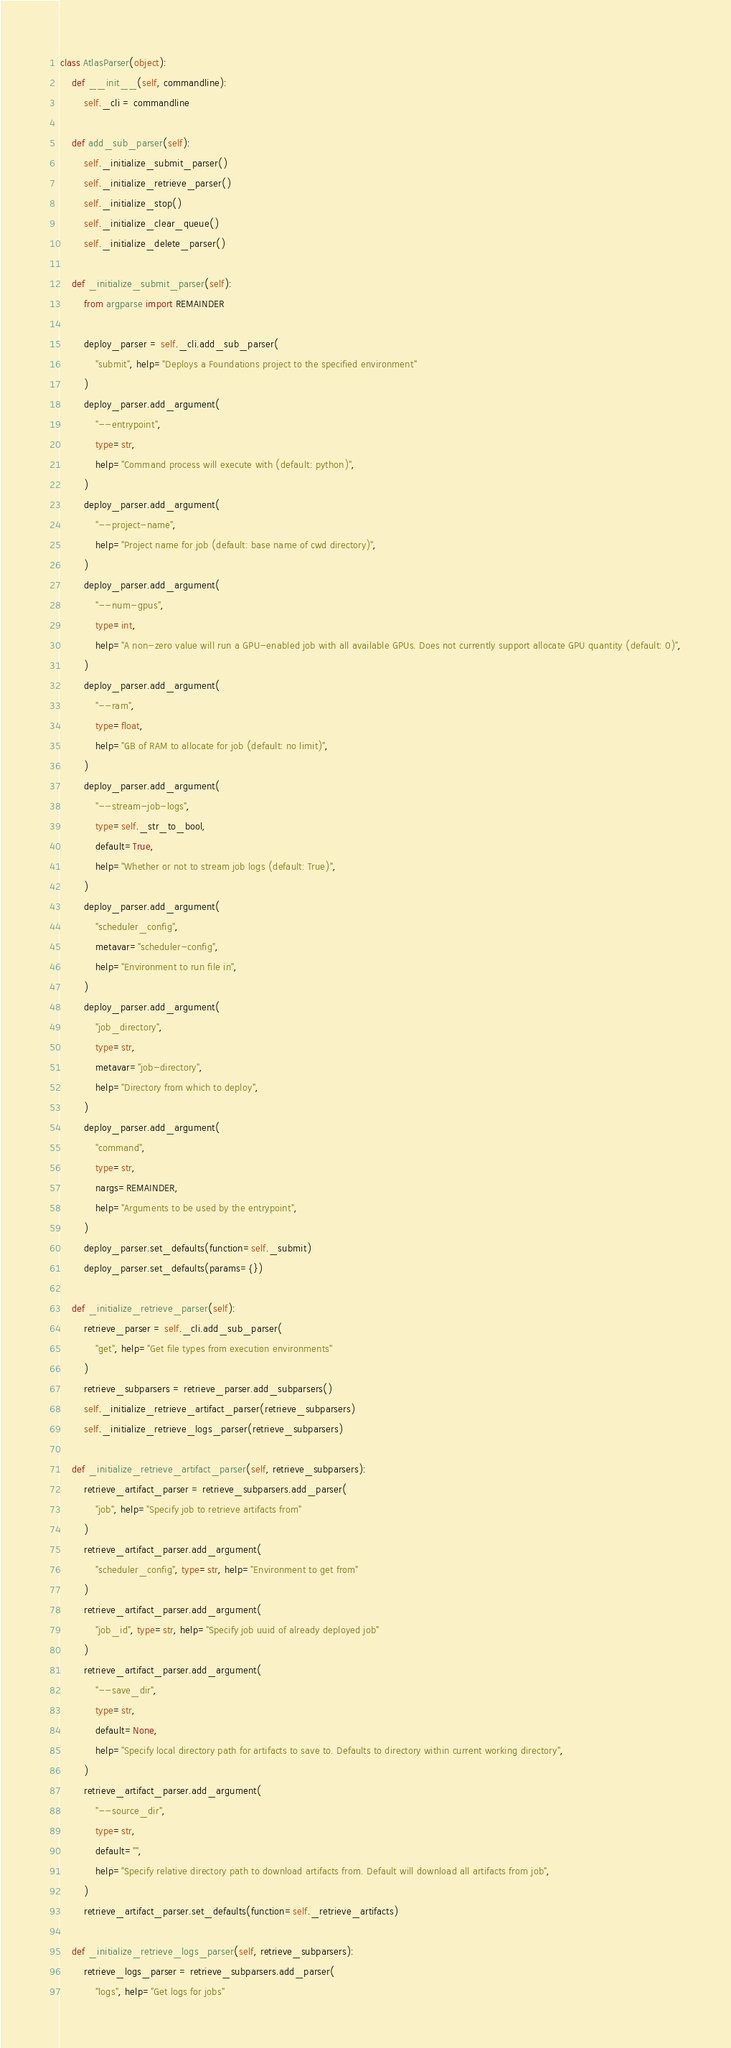Convert code to text. <code><loc_0><loc_0><loc_500><loc_500><_Python_>

class AtlasParser(object):
    def __init__(self, commandline):
        self._cli = commandline

    def add_sub_parser(self):
        self._initialize_submit_parser()
        self._initialize_retrieve_parser()
        self._initialize_stop()
        self._initialize_clear_queue()
        self._initialize_delete_parser()

    def _initialize_submit_parser(self):
        from argparse import REMAINDER

        deploy_parser = self._cli.add_sub_parser(
            "submit", help="Deploys a Foundations project to the specified environment"
        )
        deploy_parser.add_argument(
            "--entrypoint",
            type=str,
            help="Command process will execute with (default: python)",
        )
        deploy_parser.add_argument(
            "--project-name",
            help="Project name for job (default: base name of cwd directory)",
        )
        deploy_parser.add_argument(
            "--num-gpus",
            type=int,
            help="A non-zero value will run a GPU-enabled job with all available GPUs. Does not currently support allocate GPU quantity (default: 0)",
        )
        deploy_parser.add_argument(
            "--ram",
            type=float,
            help="GB of RAM to allocate for job (default: no limit)",
        )
        deploy_parser.add_argument(
            "--stream-job-logs",
            type=self._str_to_bool,
            default=True,
            help="Whether or not to stream job logs (default: True)",
        )
        deploy_parser.add_argument(
            "scheduler_config",
            metavar="scheduler-config",
            help="Environment to run file in",
        )
        deploy_parser.add_argument(
            "job_directory",
            type=str,
            metavar="job-directory",
            help="Directory from which to deploy",
        )
        deploy_parser.add_argument(
            "command",
            type=str,
            nargs=REMAINDER,
            help="Arguments to be used by the entrypoint",
        )
        deploy_parser.set_defaults(function=self._submit)
        deploy_parser.set_defaults(params={})

    def _initialize_retrieve_parser(self):
        retrieve_parser = self._cli.add_sub_parser(
            "get", help="Get file types from execution environments"
        )
        retrieve_subparsers = retrieve_parser.add_subparsers()
        self._initialize_retrieve_artifact_parser(retrieve_subparsers)
        self._initialize_retrieve_logs_parser(retrieve_subparsers)

    def _initialize_retrieve_artifact_parser(self, retrieve_subparsers):
        retrieve_artifact_parser = retrieve_subparsers.add_parser(
            "job", help="Specify job to retrieve artifacts from"
        )
        retrieve_artifact_parser.add_argument(
            "scheduler_config", type=str, help="Environment to get from"
        )
        retrieve_artifact_parser.add_argument(
            "job_id", type=str, help="Specify job uuid of already deployed job"
        )
        retrieve_artifact_parser.add_argument(
            "--save_dir",
            type=str,
            default=None,
            help="Specify local directory path for artifacts to save to. Defaults to directory within current working directory",
        )
        retrieve_artifact_parser.add_argument(
            "--source_dir",
            type=str,
            default="",
            help="Specify relative directory path to download artifacts from. Default will download all artifacts from job",
        )
        retrieve_artifact_parser.set_defaults(function=self._retrieve_artifacts)

    def _initialize_retrieve_logs_parser(self, retrieve_subparsers):
        retrieve_logs_parser = retrieve_subparsers.add_parser(
            "logs", help="Get logs for jobs"</code> 